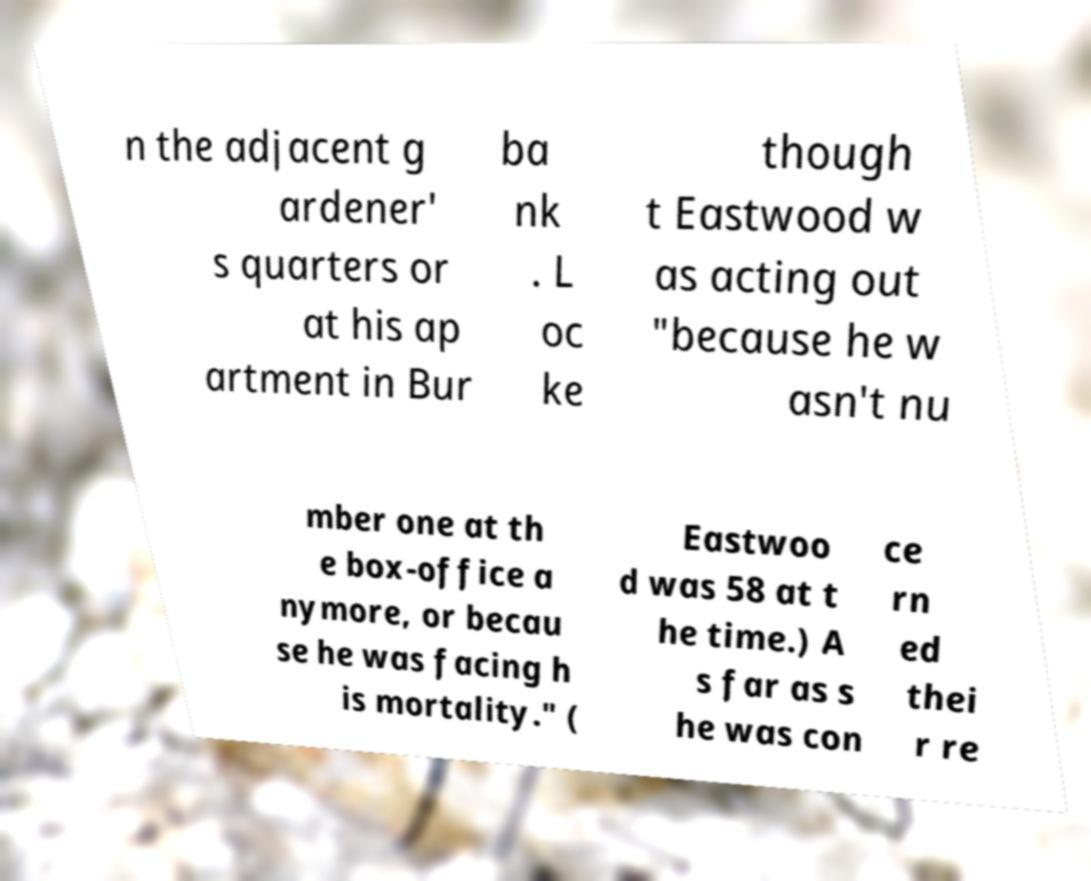Please identify and transcribe the text found in this image. n the adjacent g ardener' s quarters or at his ap artment in Bur ba nk . L oc ke though t Eastwood w as acting out "because he w asn't nu mber one at th e box-office a nymore, or becau se he was facing h is mortality." ( Eastwoo d was 58 at t he time.) A s far as s he was con ce rn ed thei r re 